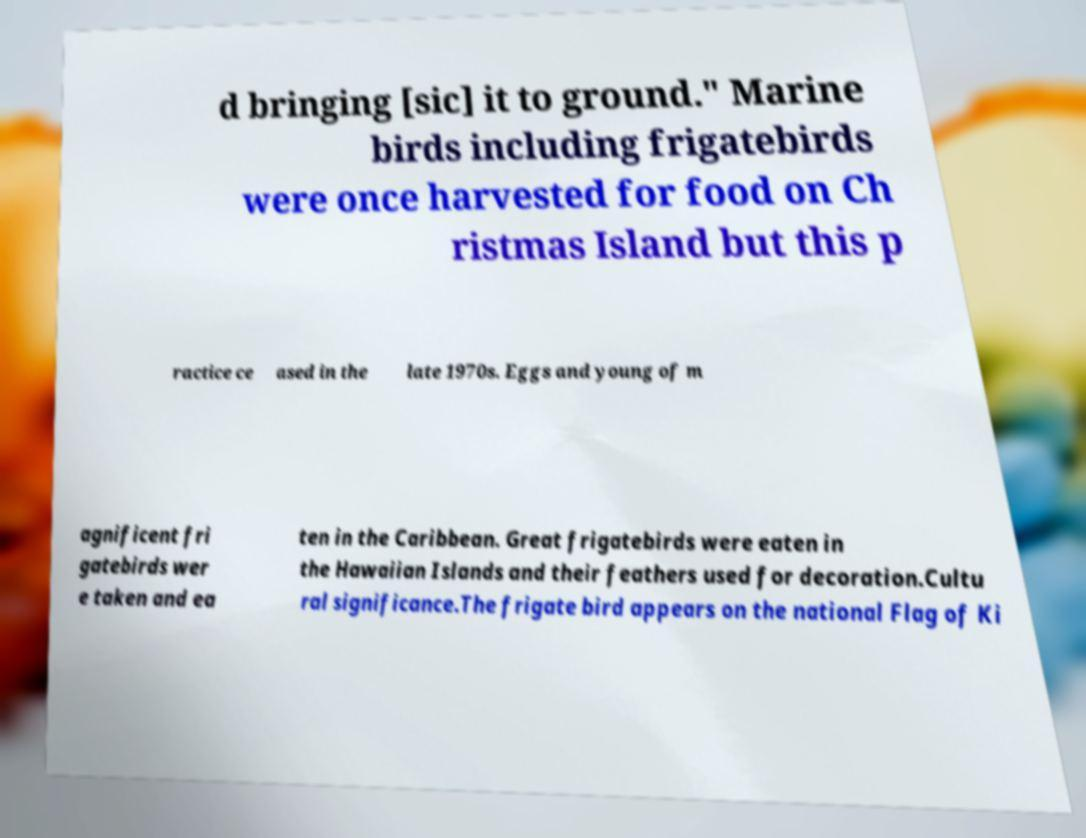Please identify and transcribe the text found in this image. d bringing [sic] it to ground." Marine birds including frigatebirds were once harvested for food on Ch ristmas Island but this p ractice ce ased in the late 1970s. Eggs and young of m agnificent fri gatebirds wer e taken and ea ten in the Caribbean. Great frigatebirds were eaten in the Hawaiian Islands and their feathers used for decoration.Cultu ral significance.The frigate bird appears on the national Flag of Ki 